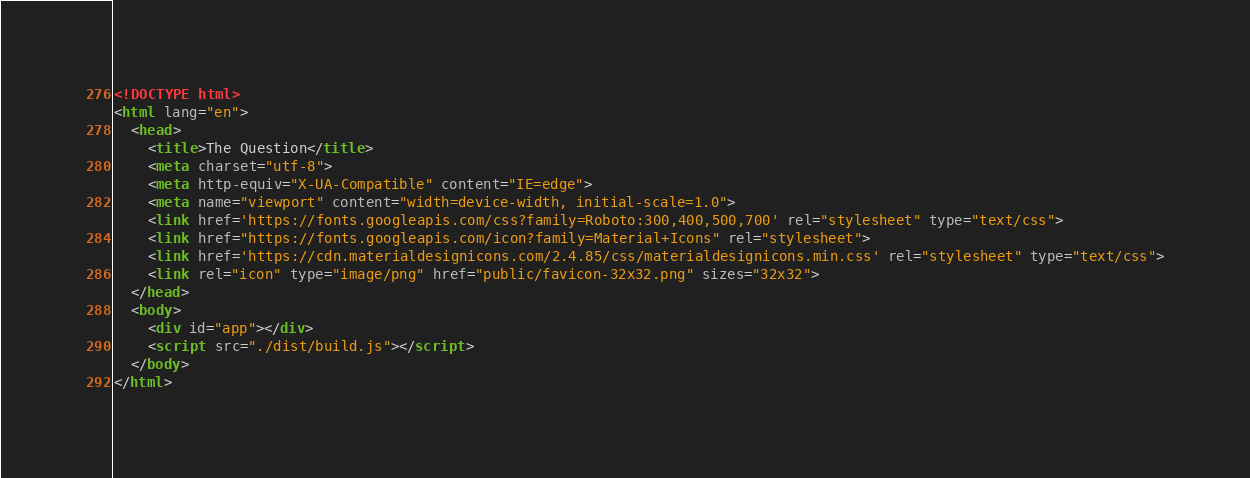<code> <loc_0><loc_0><loc_500><loc_500><_HTML_><!DOCTYPE html>
<html lang="en">
  <head>
    <title>The Question</title>
    <meta charset="utf-8">
    <meta http-equiv="X-UA-Compatible" content="IE=edge">
    <meta name="viewport" content="width=device-width, initial-scale=1.0">
    <link href='https://fonts.googleapis.com/css?family=Roboto:300,400,500,700' rel="stylesheet" type="text/css">
    <link href="https://fonts.googleapis.com/icon?family=Material+Icons" rel="stylesheet">
    <link href='https://cdn.materialdesignicons.com/2.4.85/css/materialdesignicons.min.css' rel="stylesheet" type="text/css">
    <link rel="icon" type="image/png" href="public/favicon-32x32.png" sizes="32x32">
  </head>
  <body>
    <div id="app"></div>
    <script src="./dist/build.js"></script>
  </body>
</html>
</code> 